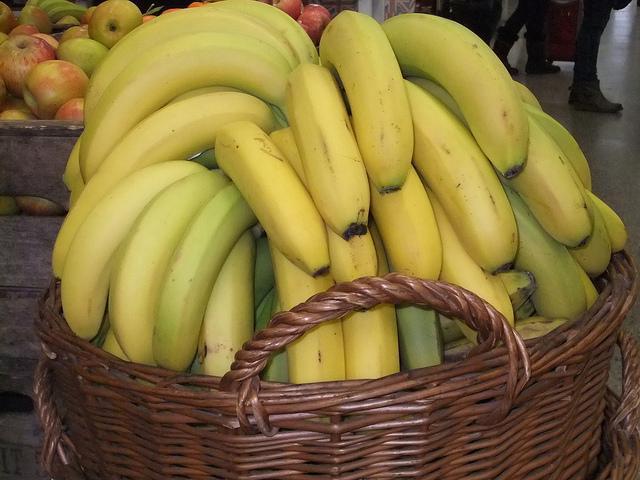What pome fruits are shown here?
Select the accurate response from the four choices given to answer the question.
Options: Oranges, cherries, bananas, apples. Apples. 